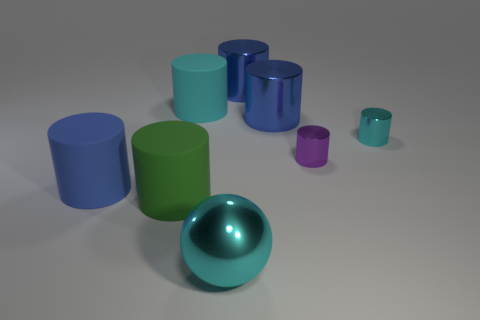Can you tell me which objects in the picture are reflective? Certainly, in the picture we see that the cyan-colored sphere and the various cylinders exhibit a reflective surface, which can be identified by the presence of highlights and the way they mirror the environment. 